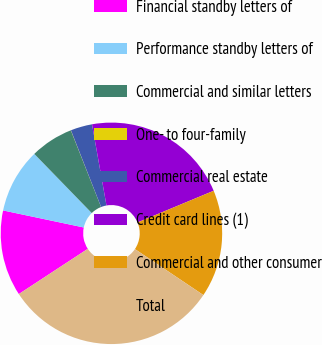<chart> <loc_0><loc_0><loc_500><loc_500><pie_chart><fcel>Financial standby letters of<fcel>Performance standby letters of<fcel>Commercial and similar letters<fcel>One- to four-family<fcel>Commercial real estate<fcel>Credit card lines (1)<fcel>Commercial and other consumer<fcel>Total<nl><fcel>12.55%<fcel>9.42%<fcel>6.29%<fcel>0.02%<fcel>3.15%<fcel>21.53%<fcel>15.69%<fcel>31.35%<nl></chart> 